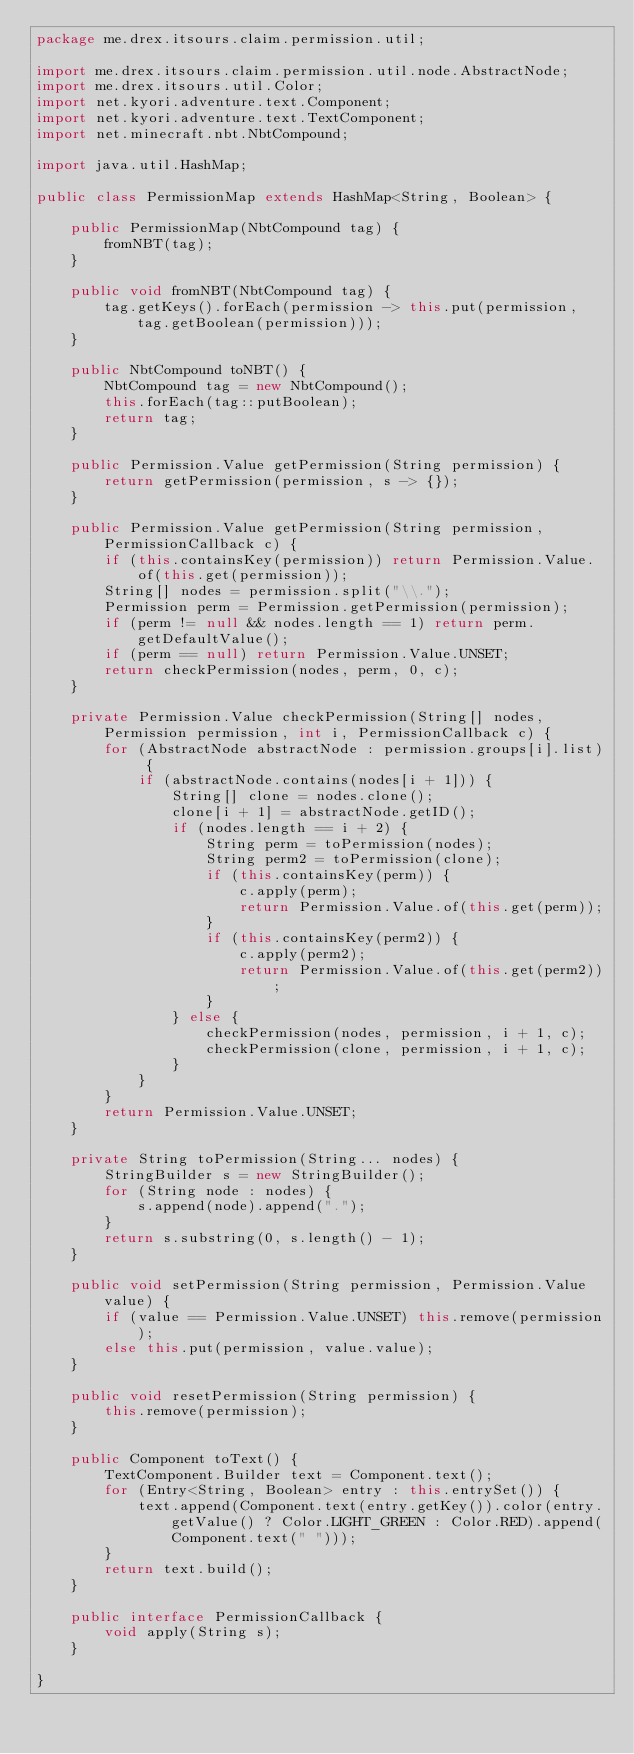Convert code to text. <code><loc_0><loc_0><loc_500><loc_500><_Java_>package me.drex.itsours.claim.permission.util;

import me.drex.itsours.claim.permission.util.node.AbstractNode;
import me.drex.itsours.util.Color;
import net.kyori.adventure.text.Component;
import net.kyori.adventure.text.TextComponent;
import net.minecraft.nbt.NbtCompound;

import java.util.HashMap;

public class PermissionMap extends HashMap<String, Boolean> {

    public PermissionMap(NbtCompound tag) {
        fromNBT(tag);
    }

    public void fromNBT(NbtCompound tag) {
        tag.getKeys().forEach(permission -> this.put(permission, tag.getBoolean(permission)));
    }

    public NbtCompound toNBT() {
        NbtCompound tag = new NbtCompound();
        this.forEach(tag::putBoolean);
        return tag;
    }

    public Permission.Value getPermission(String permission) {
        return getPermission(permission, s -> {});
    }

    public Permission.Value getPermission(String permission, PermissionCallback c) {
        if (this.containsKey(permission)) return Permission.Value.of(this.get(permission));
        String[] nodes = permission.split("\\.");
        Permission perm = Permission.getPermission(permission);
        if (perm != null && nodes.length == 1) return perm.getDefaultValue();
        if (perm == null) return Permission.Value.UNSET;
        return checkPermission(nodes, perm, 0, c);
    }

    private Permission.Value checkPermission(String[] nodes, Permission permission, int i, PermissionCallback c) {
        for (AbstractNode abstractNode : permission.groups[i].list) {
            if (abstractNode.contains(nodes[i + 1])) {
                String[] clone = nodes.clone();
                clone[i + 1] = abstractNode.getID();
                if (nodes.length == i + 2) {
                    String perm = toPermission(nodes);
                    String perm2 = toPermission(clone);
                    if (this.containsKey(perm)) {
                        c.apply(perm);
                        return Permission.Value.of(this.get(perm));
                    }
                    if (this.containsKey(perm2)) {
                        c.apply(perm2);
                        return Permission.Value.of(this.get(perm2));
                    }
                } else {
                    checkPermission(nodes, permission, i + 1, c);
                    checkPermission(clone, permission, i + 1, c);
                }
            }
        }
        return Permission.Value.UNSET;
    }

    private String toPermission(String... nodes) {
        StringBuilder s = new StringBuilder();
        for (String node : nodes) {
            s.append(node).append(".");
        }
        return s.substring(0, s.length() - 1);
    }

    public void setPermission(String permission, Permission.Value value) {
        if (value == Permission.Value.UNSET) this.remove(permission);
        else this.put(permission, value.value);
    }

    public void resetPermission(String permission) {
        this.remove(permission);
    }

    public Component toText() {
        TextComponent.Builder text = Component.text();
        for (Entry<String, Boolean> entry : this.entrySet()) {
            text.append(Component.text(entry.getKey()).color(entry.getValue() ? Color.LIGHT_GREEN : Color.RED).append(Component.text(" ")));
        }
        return text.build();
    }

    public interface PermissionCallback {
        void apply(String s);
    }

}
</code> 